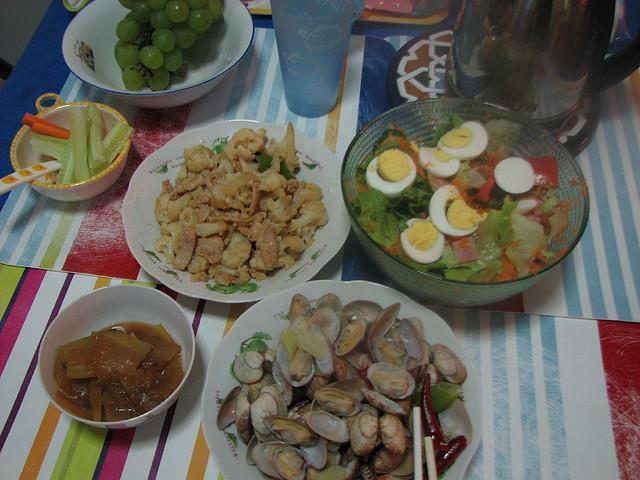How many plates are there?
Give a very brief answer. 2. How many bowls can you see?
Give a very brief answer. 4. 